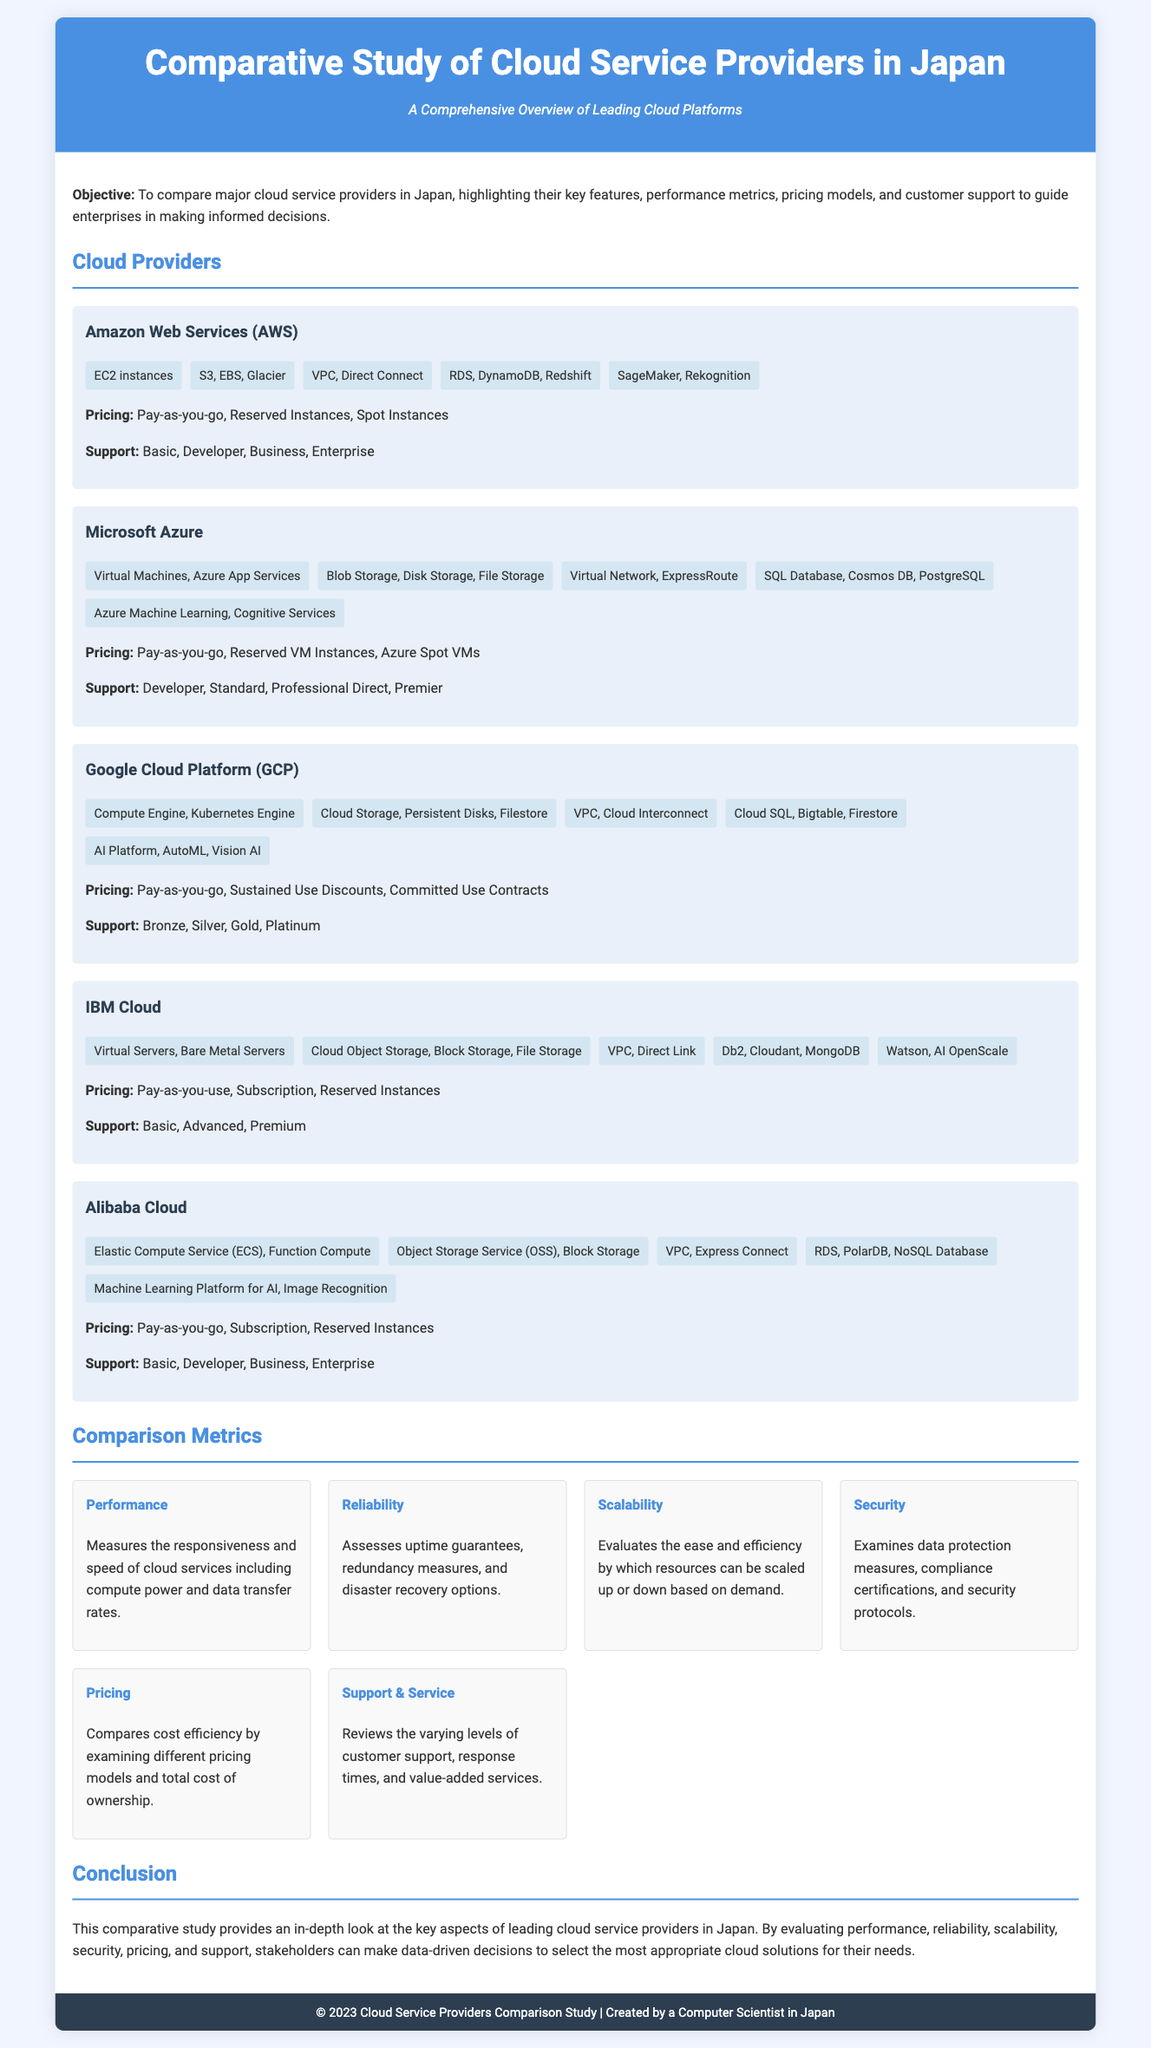What is the title of the document? The title of the document is specified in the header section, which is "Comparative Study of Cloud Service Providers in Japan."
Answer: Comparative Study of Cloud Service Providers in Japan Which cloud provider offers SageMaker? SageMaker is mentioned under the features of Amazon Web Services (AWS).
Answer: Amazon Web Services (AWS) What pricing model is available for Google Cloud Platform? The pricing model for Google Cloud Platform includes "Pay-as-you-go, Sustained Use Discounts, Committed Use Contracts."
Answer: Pay-as-you-go, Sustained Use Discounts, Committed Use Contracts What is one of the comparison metrics listed in the document? The document lists various comparison metrics, one of which is "Performance."
Answer: Performance Which cloud provider has a feature called Watson? Watson is a feature listed under IBM Cloud.
Answer: IBM Cloud What type of support is available for Microsoft Azure? The support levels for Microsoft Azure are "Developer, Standard, Professional Direct, Premier."
Answer: Developer, Standard, Professional Direct, Premier How many features are listed under Alibaba Cloud? The features for Alibaba Cloud are listed, totaling five.
Answer: Five What is the objective of this study? The objective clearly states to compare major cloud service providers in Japan, highlighting key features and metrics.
Answer: To compare major cloud service providers in Japan What does the conclusion summarize? The conclusion summarizes the key aspects of leading cloud service providers in Japan and emphasizes making data-driven decisions.
Answer: Key aspects of leading cloud service providers in Japan 